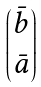<formula> <loc_0><loc_0><loc_500><loc_500>\begin{pmatrix} \bar { b } \\ \bar { a } \end{pmatrix}</formula> 